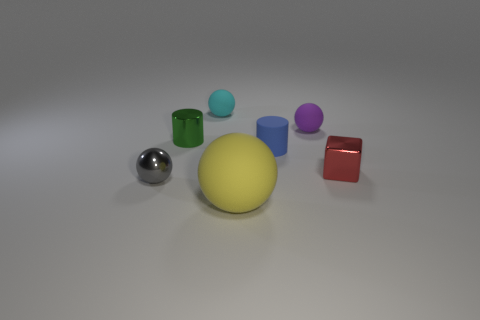Is the number of large green matte cylinders less than the number of cyan balls?
Ensure brevity in your answer.  Yes. There is another large object that is the same shape as the gray shiny object; what is its color?
Provide a succinct answer. Yellow. What is the color of the ball that is the same material as the red object?
Provide a succinct answer. Gray. How many shiny spheres are the same size as the purple matte sphere?
Your answer should be compact. 1. What is the red thing made of?
Offer a very short reply. Metal. Are there more small gray metal things than cylinders?
Offer a very short reply. No. Do the red thing and the cyan rubber object have the same shape?
Make the answer very short. No. Is there any other thing that is the same shape as the small red metal thing?
Your answer should be compact. No. Do the rubber object that is behind the purple object and the small ball in front of the purple matte object have the same color?
Your response must be concise. No. Are there fewer tiny cyan rubber balls right of the blue cylinder than large yellow matte spheres that are to the left of the metallic cylinder?
Your answer should be very brief. No. 